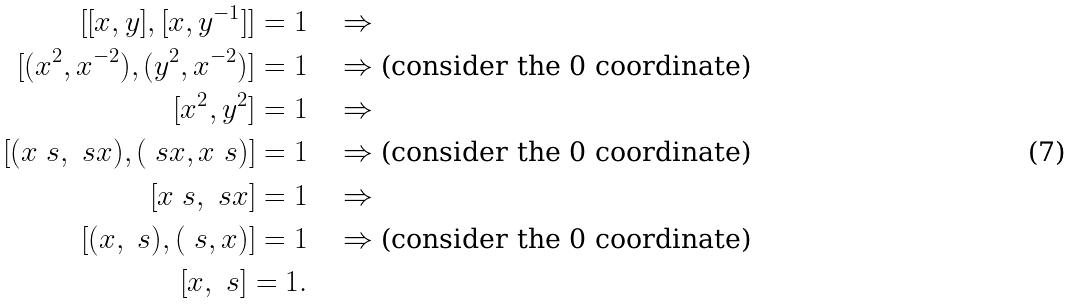Convert formula to latex. <formula><loc_0><loc_0><loc_500><loc_500>[ [ x , y ] , [ x , y ^ { - 1 } ] ] = 1 \quad & \Rightarrow \\ [ ( x ^ { 2 } , x ^ { - 2 } ) , ( y ^ { 2 } , x ^ { - 2 } ) ] = 1 \quad & \Rightarrow \text {(consider the 0 coordinate)} \\ [ x ^ { 2 } , y ^ { 2 } ] = 1 \quad & \Rightarrow \\ [ ( x \ s , \ s x ) , ( \ s x , x \ s ) ] = 1 \quad & \Rightarrow \text {(consider the 0 coordinate)} \\ [ x \ s , \ s x ] = 1 \quad & \Rightarrow \\ [ ( x , \ s ) , ( \ s , x ) ] = 1 \quad & \Rightarrow \text {(consider the 0 coordinate)} \\ [ x , \ s ] = 1 . \quad &</formula> 